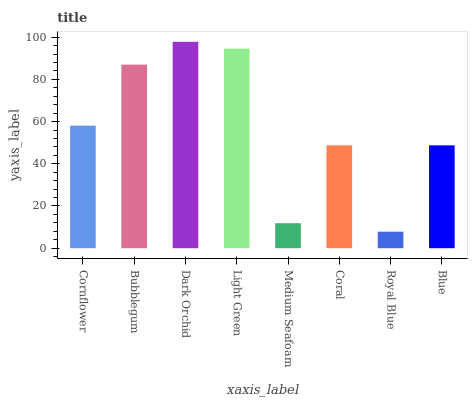Is Royal Blue the minimum?
Answer yes or no. Yes. Is Dark Orchid the maximum?
Answer yes or no. Yes. Is Bubblegum the minimum?
Answer yes or no. No. Is Bubblegum the maximum?
Answer yes or no. No. Is Bubblegum greater than Cornflower?
Answer yes or no. Yes. Is Cornflower less than Bubblegum?
Answer yes or no. Yes. Is Cornflower greater than Bubblegum?
Answer yes or no. No. Is Bubblegum less than Cornflower?
Answer yes or no. No. Is Cornflower the high median?
Answer yes or no. Yes. Is Coral the low median?
Answer yes or no. Yes. Is Coral the high median?
Answer yes or no. No. Is Bubblegum the low median?
Answer yes or no. No. 